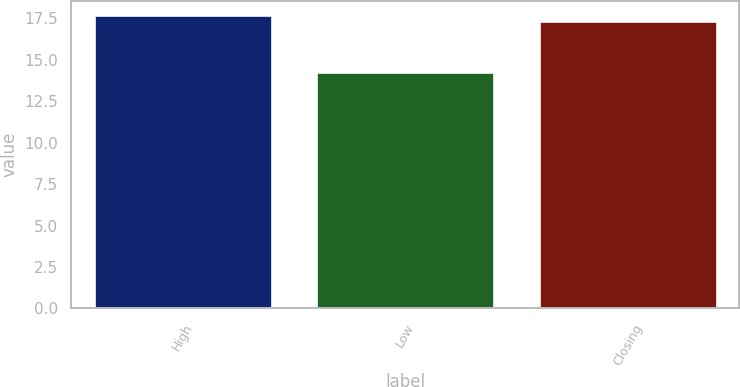Convert chart. <chart><loc_0><loc_0><loc_500><loc_500><bar_chart><fcel>High<fcel>Low<fcel>Closing<nl><fcel>17.68<fcel>14.29<fcel>17.36<nl></chart> 